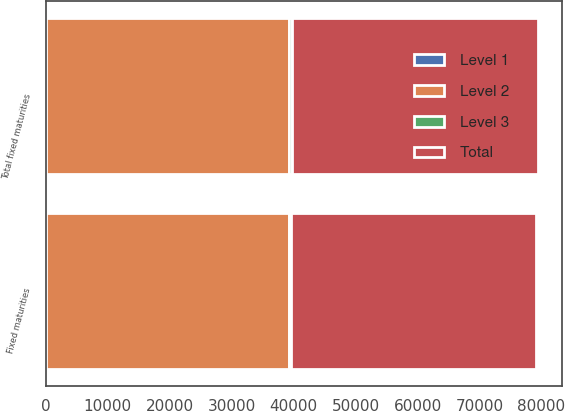<chart> <loc_0><loc_0><loc_500><loc_500><stacked_bar_chart><ecel><fcel>Fixed maturities<fcel>Total fixed maturities<nl><fcel>Level 1<fcel>101<fcel>101<nl><fcel>Level 2<fcel>39101<fcel>39136<nl><fcel>Level 3<fcel>379<fcel>464<nl><fcel>Total<fcel>39581<fcel>39701<nl></chart> 